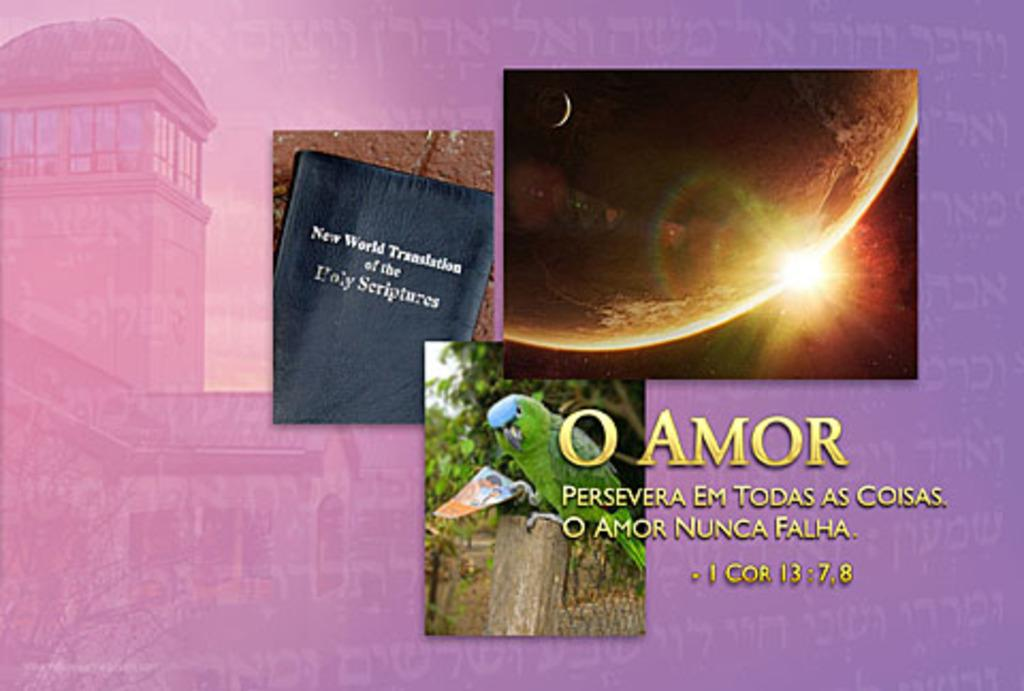<image>
Share a concise interpretation of the image provided. A Bible quote from I Cor 13:7,8 next to a New World Translation of the Holy Scriptures 